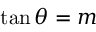Convert formula to latex. <formula><loc_0><loc_0><loc_500><loc_500>\tan \theta = m</formula> 